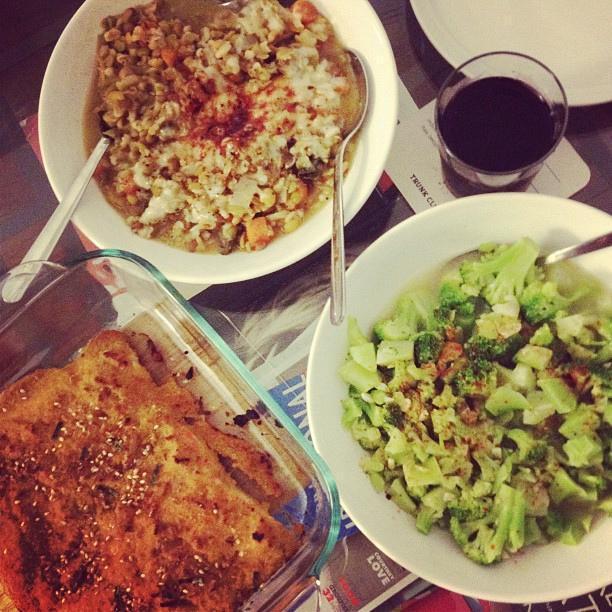How many spoons are there?
Give a very brief answer. 2. How many bowls are visible?
Give a very brief answer. 2. How many broccolis are in the picture?
Give a very brief answer. 6. How many sheep are there?
Give a very brief answer. 0. 